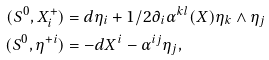<formula> <loc_0><loc_0><loc_500><loc_500>( S ^ { 0 } , X _ { i } ^ { + } ) & = d \eta _ { i } + 1 / 2 \partial _ { i } \alpha ^ { k l } ( X ) \eta _ { k } \wedge \eta _ { j } \\ ( S ^ { 0 } , \eta ^ { + i } ) & = - d X ^ { i } - \alpha ^ { i j } \eta _ { j } ,</formula> 